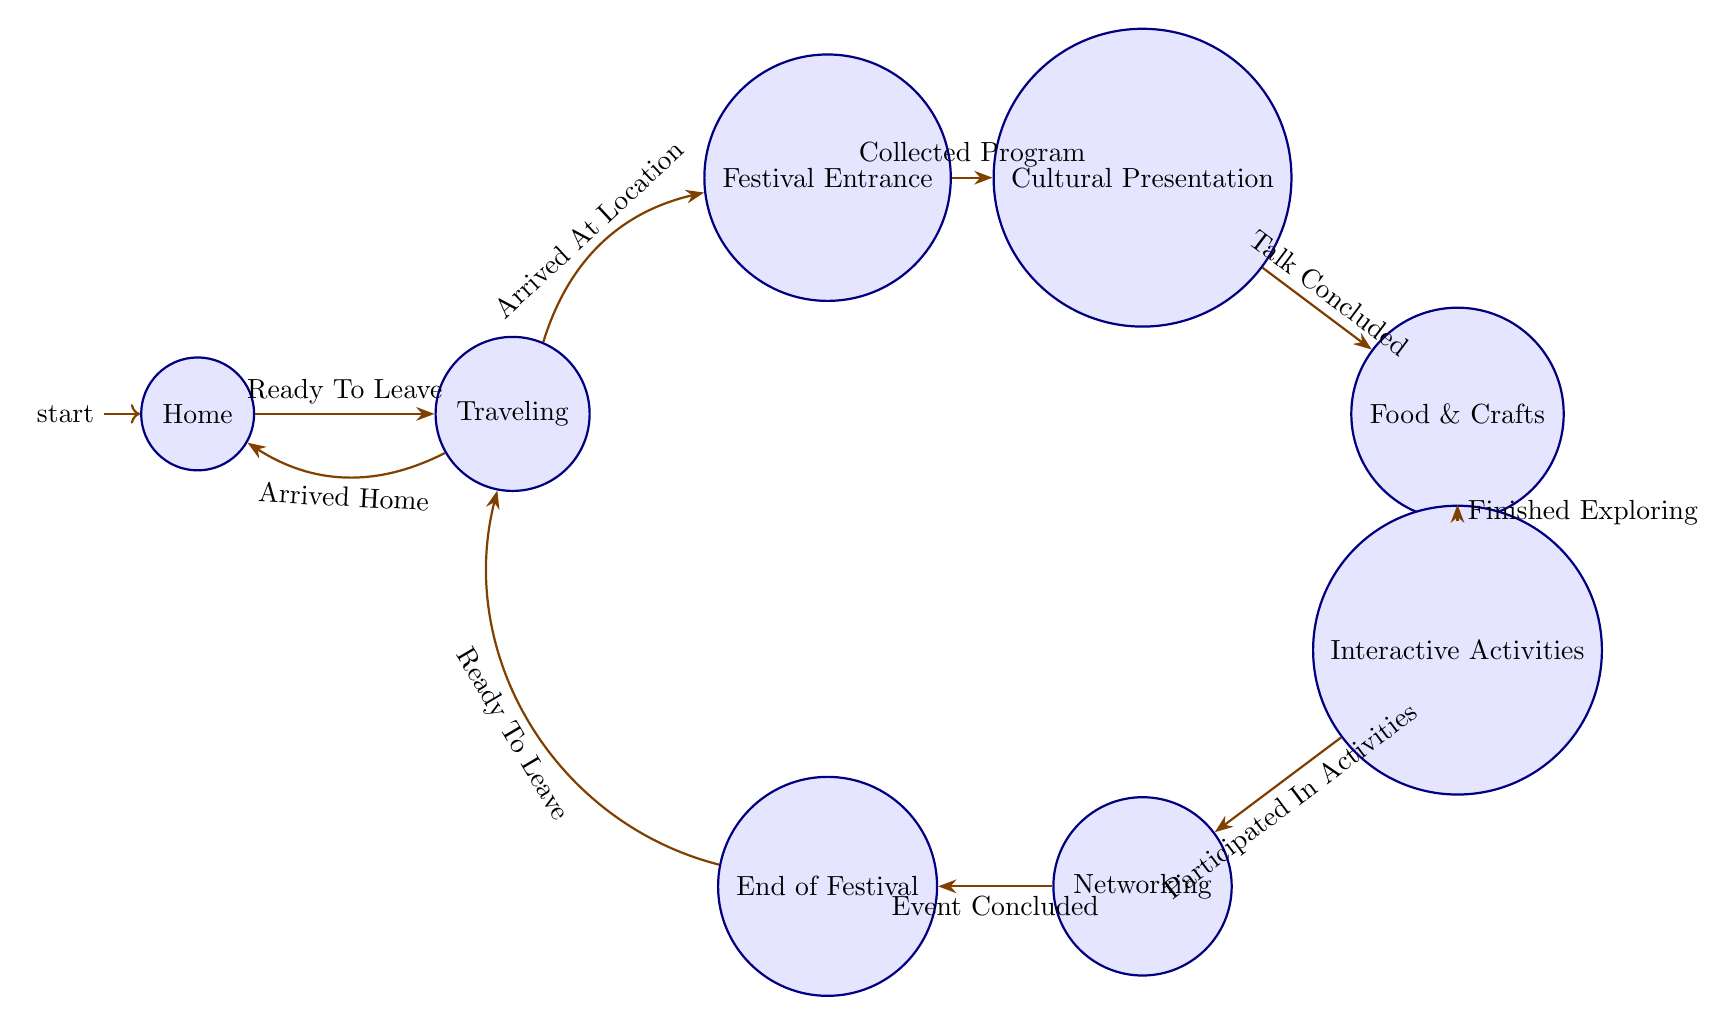What is the starting state of the diagram? The diagram begins at the "Home" state, which is indicated as the initial node in the diagram.
Answer: Home How many total states are present in the diagram? By counting the individual states listed (Home, Traveling, Festival Entrance, Cultural Presentation, Food and Crafts, Interactive Activities, Networking, End of Festival), we find a total of 8 states.
Answer: 8 What action is taken when transitioning from "Home" to "Traveling"? The transition from "Home" to "Traveling" is triggered by the action "Ready To Leave", as indicated by the corresponding edge in the diagram.
Answer: Ready To Leave Which state follows "Cultural Presentation"? After "Cultural Presentation", the next state is "Food and Crafts", as shown in the directed transition indicated in the diagram.
Answer: Food and Crafts What is the last state before returning home after the festival? The last state before going back home is "End of Festival", as it transitions back to "Traveling", indicating preparation to leave.
Answer: End of Festival What action leads to the state "Networking"? The state "Networking" is reached after the action "Participated In Activities" is completed, connecting "Interactive Activities" to "Networking".
Answer: Participated In Activities If arriving at the location, which state will be entered next? Upon arriving at the location, the next state entered is "Festival Entrance", as indicated by the transition triggered by "Arrived At Location".
Answer: Festival Entrance What action must be completed to move from "Food and Crafts" to "Interactive Activities"? To move from "Food and Crafts" to "Interactive Activities", the action "Finished Exploring" must be completed, which allows the transition to occur according to the diagram.
Answer: Finished Exploring 